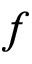<formula> <loc_0><loc_0><loc_500><loc_500>f</formula> 